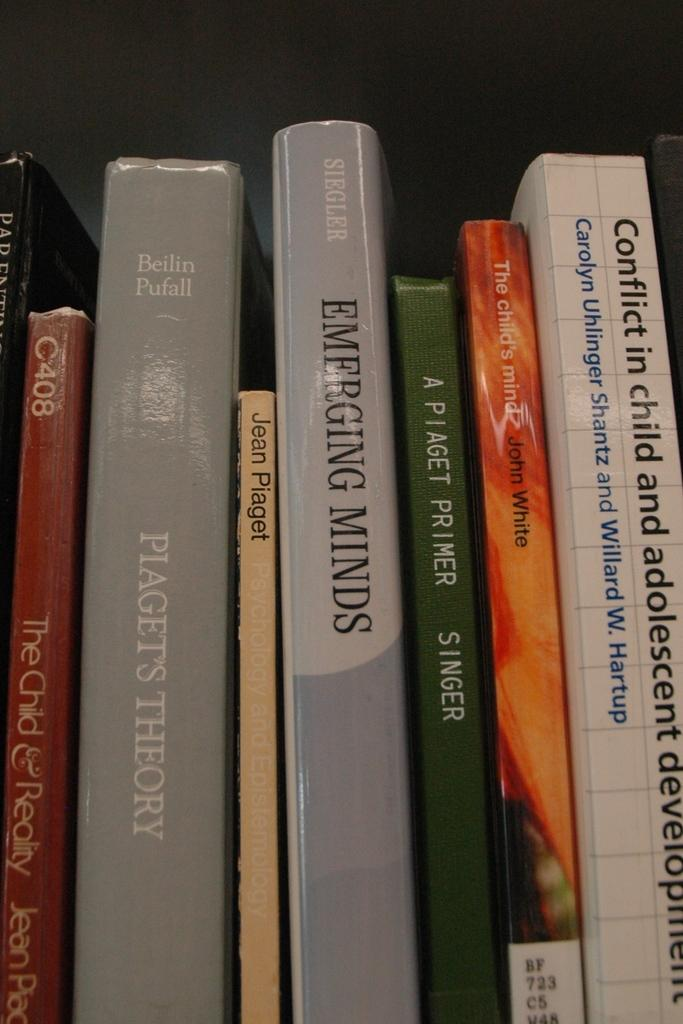Provide a one-sentence caption for the provided image. a line of books with one of them that is called 'emerging minds'. 